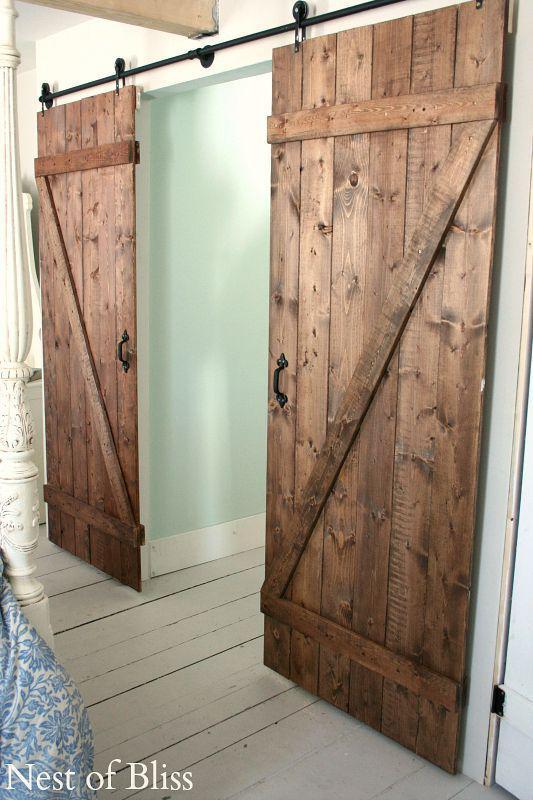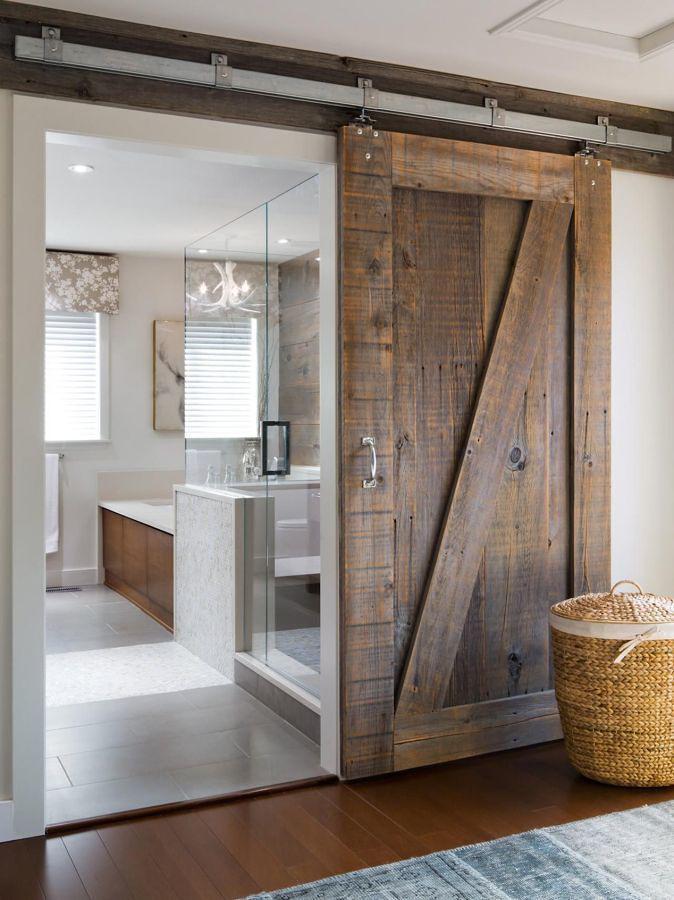The first image is the image on the left, the second image is the image on the right. Analyze the images presented: Is the assertion "One image shows a two-paneled barn door with angled wood trim and no windows." valid? Answer yes or no. Yes. 